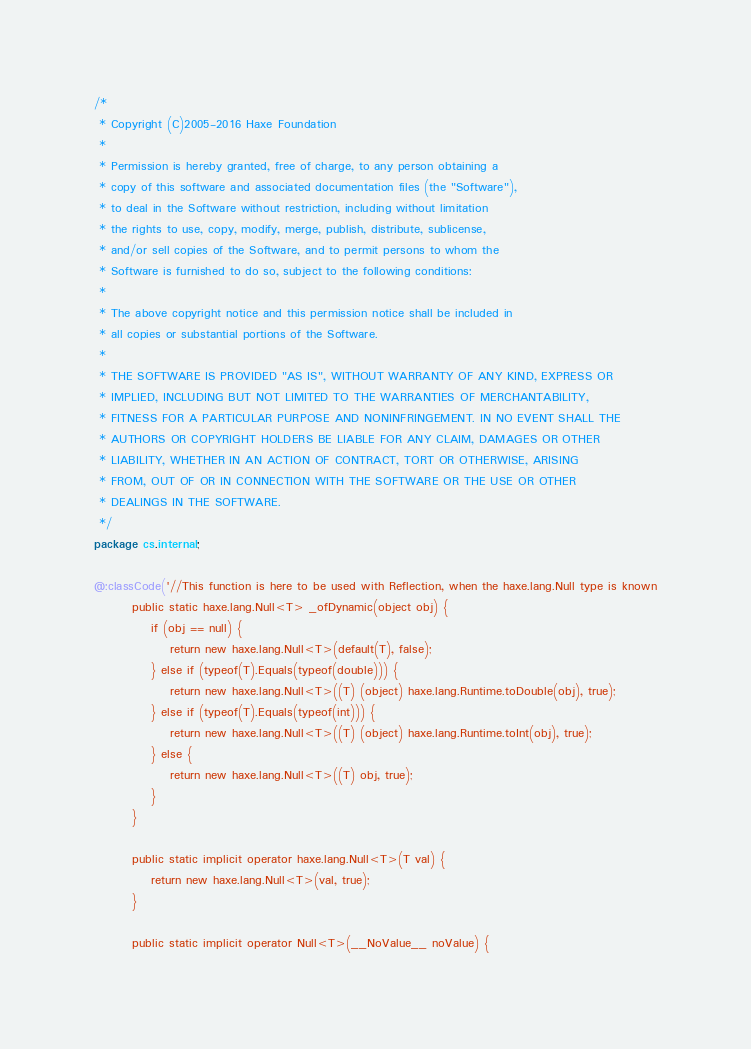Convert code to text. <code><loc_0><loc_0><loc_500><loc_500><_Haxe_>/*
 * Copyright (C)2005-2016 Haxe Foundation
 *
 * Permission is hereby granted, free of charge, to any person obtaining a
 * copy of this software and associated documentation files (the "Software"),
 * to deal in the Software without restriction, including without limitation
 * the rights to use, copy, modify, merge, publish, distribute, sublicense,
 * and/or sell copies of the Software, and to permit persons to whom the
 * Software is furnished to do so, subject to the following conditions:
 *
 * The above copyright notice and this permission notice shall be included in
 * all copies or substantial portions of the Software.
 *
 * THE SOFTWARE IS PROVIDED "AS IS", WITHOUT WARRANTY OF ANY KIND, EXPRESS OR
 * IMPLIED, INCLUDING BUT NOT LIMITED TO THE WARRANTIES OF MERCHANTABILITY,
 * FITNESS FOR A PARTICULAR PURPOSE AND NONINFRINGEMENT. IN NO EVENT SHALL THE
 * AUTHORS OR COPYRIGHT HOLDERS BE LIABLE FOR ANY CLAIM, DAMAGES OR OTHER
 * LIABILITY, WHETHER IN AN ACTION OF CONTRACT, TORT OR OTHERWISE, ARISING
 * FROM, OUT OF OR IN CONNECTION WITH THE SOFTWARE OR THE USE OR OTHER
 * DEALINGS IN THE SOFTWARE.
 */
package cs.internal;

@:classCode('//This function is here to be used with Reflection, when the haxe.lang.Null type is known
		public static haxe.lang.Null<T> _ofDynamic(object obj) {
			if (obj == null) {
				return new haxe.lang.Null<T>(default(T), false);
			} else if (typeof(T).Equals(typeof(double))) {
				return new haxe.lang.Null<T>((T) (object) haxe.lang.Runtime.toDouble(obj), true);
			} else if (typeof(T).Equals(typeof(int))) {
				return new haxe.lang.Null<T>((T) (object) haxe.lang.Runtime.toInt(obj), true);
			} else {
				return new haxe.lang.Null<T>((T) obj, true);
			}
		}

		public static implicit operator haxe.lang.Null<T>(T val) {
			return new haxe.lang.Null<T>(val, true);
		}

		public static implicit operator Null<T>(__NoValue__ noValue) {</code> 